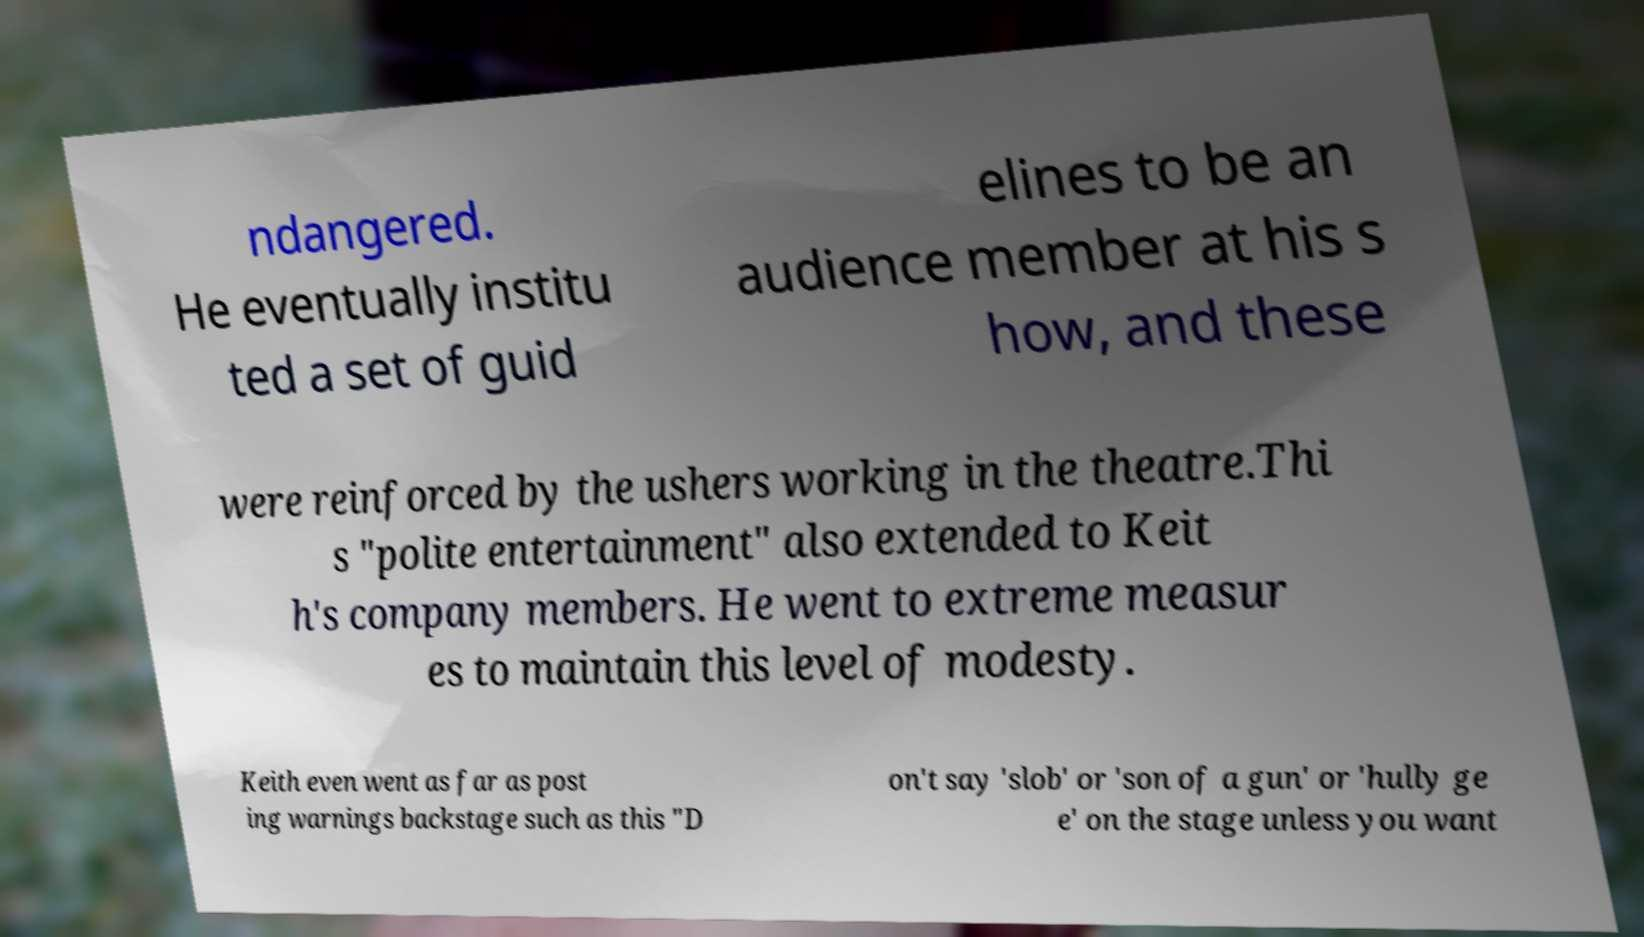Can you read and provide the text displayed in the image?This photo seems to have some interesting text. Can you extract and type it out for me? ndangered. He eventually institu ted a set of guid elines to be an audience member at his s how, and these were reinforced by the ushers working in the theatre.Thi s "polite entertainment" also extended to Keit h's company members. He went to extreme measur es to maintain this level of modesty. Keith even went as far as post ing warnings backstage such as this "D on't say 'slob' or 'son of a gun' or 'hully ge e' on the stage unless you want 